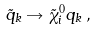<formula> <loc_0><loc_0><loc_500><loc_500>\tilde { q } _ { k } \rightarrow \tilde { \chi } ^ { 0 } _ { i } q _ { k } \, ,</formula> 